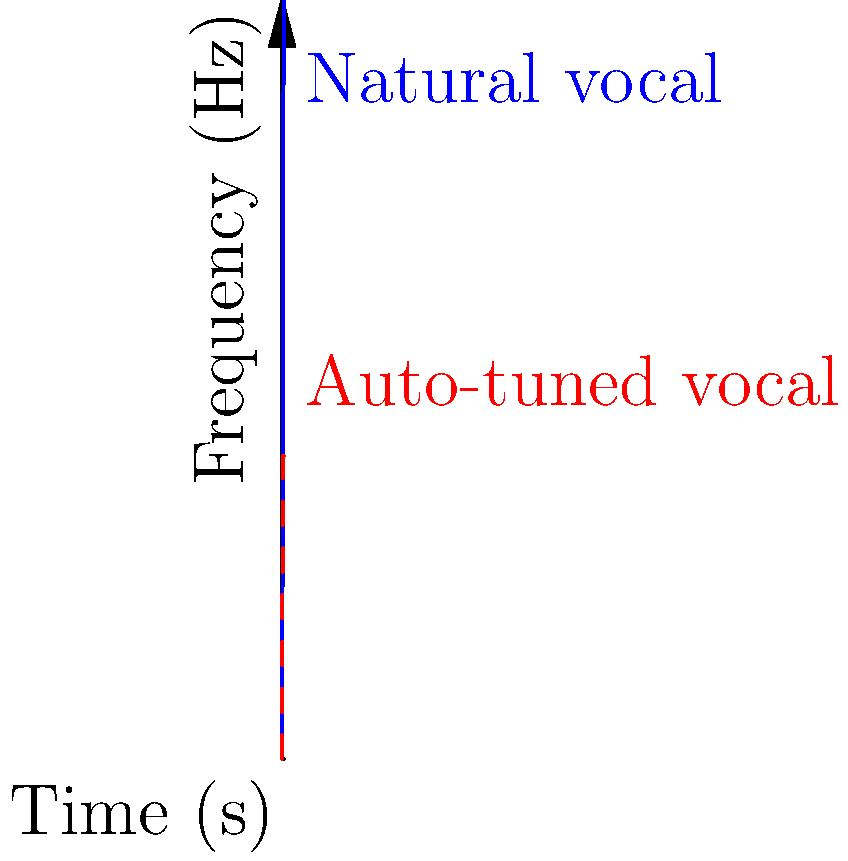As a keen observer of The X Factor performances, you've noticed some contestants might be using auto-tune. Looking at the spectrogram above, which line represents the likely auto-tuned vocals, and what characteristic gives it away? To identify auto-tuned vocals in a spectrogram, we need to understand the differences between natural and processed vocals:

1. Natural vocals (blue line):
   - Show more variation in frequency over time
   - Have a smoother, more organic curve
   - Frequencies change gradually as the singer moves through different notes

2. Auto-tuned vocals (red dashed line):
   - Display less natural variation
   - Have sudden, sharp changes in frequency
   - Often show perfectly flat lines for sustained notes

In this spectrogram:
- The blue line represents natural vocals, with a gradual increase in frequency over time.
- The red dashed line shows characteristics of auto-tuned vocals:
  a) It has a sudden plateau at around 2000 Hz
  b) This plateau remains perfectly flat from 4 seconds to 10 seconds

The key giveaway for auto-tuned vocals is the unnaturally flat and sustained frequency line, which is difficult to achieve with a natural human voice. This is represented by the red dashed line in the spectrogram.
Answer: Red dashed line; unnaturally flat sustained frequency 